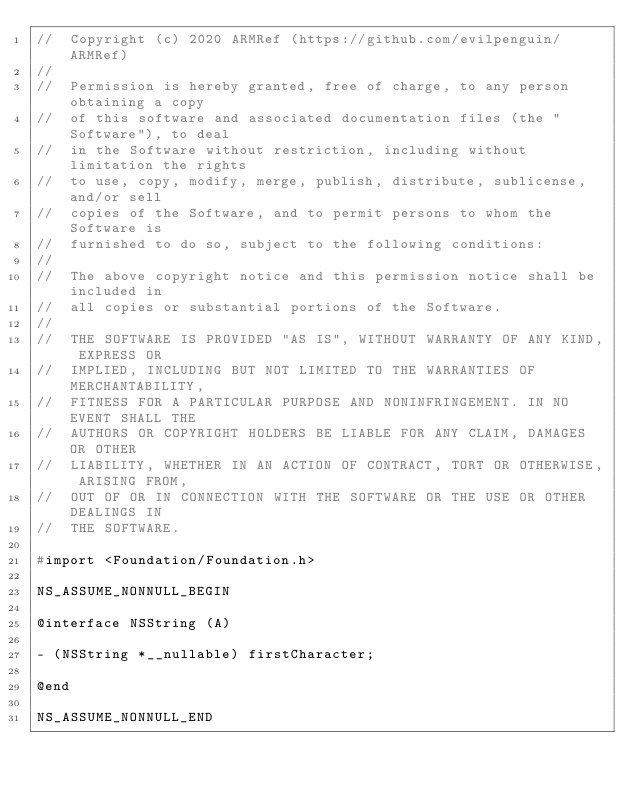<code> <loc_0><loc_0><loc_500><loc_500><_C_>//  Copyright (c) 2020 ARMRef (https://github.com/evilpenguin/ARMRef)
//
//  Permission is hereby granted, free of charge, to any person obtaining a copy
//  of this software and associated documentation files (the "Software"), to deal
//  in the Software without restriction, including without limitation the rights
//  to use, copy, modify, merge, publish, distribute, sublicense, and/or sell
//  copies of the Software, and to permit persons to whom the Software is
//  furnished to do so, subject to the following conditions:
//
//  The above copyright notice and this permission notice shall be included in
//  all copies or substantial portions of the Software.
//
//  THE SOFTWARE IS PROVIDED "AS IS", WITHOUT WARRANTY OF ANY KIND, EXPRESS OR
//  IMPLIED, INCLUDING BUT NOT LIMITED TO THE WARRANTIES OF MERCHANTABILITY,
//  FITNESS FOR A PARTICULAR PURPOSE AND NONINFRINGEMENT. IN NO EVENT SHALL THE
//  AUTHORS OR COPYRIGHT HOLDERS BE LIABLE FOR ANY CLAIM, DAMAGES OR OTHER
//  LIABILITY, WHETHER IN AN ACTION OF CONTRACT, TORT OR OTHERWISE, ARISING FROM,
//  OUT OF OR IN CONNECTION WITH THE SOFTWARE OR THE USE OR OTHER DEALINGS IN
//  THE SOFTWARE.

#import <Foundation/Foundation.h>

NS_ASSUME_NONNULL_BEGIN

@interface NSString (A)

- (NSString *__nullable) firstCharacter;

@end

NS_ASSUME_NONNULL_END
</code> 